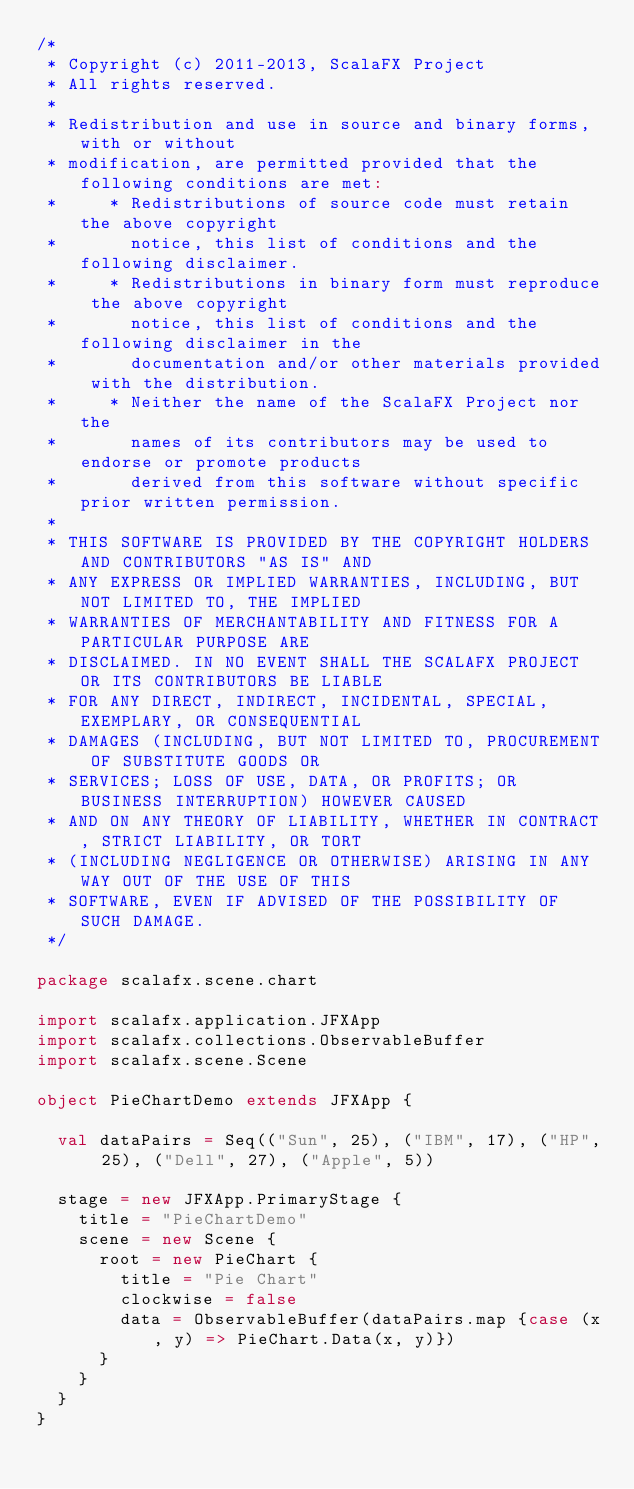<code> <loc_0><loc_0><loc_500><loc_500><_Scala_>/*
 * Copyright (c) 2011-2013, ScalaFX Project
 * All rights reserved.
 *
 * Redistribution and use in source and binary forms, with or without
 * modification, are permitted provided that the following conditions are met:
 *     * Redistributions of source code must retain the above copyright
 *       notice, this list of conditions and the following disclaimer.
 *     * Redistributions in binary form must reproduce the above copyright
 *       notice, this list of conditions and the following disclaimer in the
 *       documentation and/or other materials provided with the distribution.
 *     * Neither the name of the ScalaFX Project nor the
 *       names of its contributors may be used to endorse or promote products
 *       derived from this software without specific prior written permission.
 *
 * THIS SOFTWARE IS PROVIDED BY THE COPYRIGHT HOLDERS AND CONTRIBUTORS "AS IS" AND
 * ANY EXPRESS OR IMPLIED WARRANTIES, INCLUDING, BUT NOT LIMITED TO, THE IMPLIED
 * WARRANTIES OF MERCHANTABILITY AND FITNESS FOR A PARTICULAR PURPOSE ARE
 * DISCLAIMED. IN NO EVENT SHALL THE SCALAFX PROJECT OR ITS CONTRIBUTORS BE LIABLE
 * FOR ANY DIRECT, INDIRECT, INCIDENTAL, SPECIAL, EXEMPLARY, OR CONSEQUENTIAL
 * DAMAGES (INCLUDING, BUT NOT LIMITED TO, PROCUREMENT OF SUBSTITUTE GOODS OR
 * SERVICES; LOSS OF USE, DATA, OR PROFITS; OR BUSINESS INTERRUPTION) HOWEVER CAUSED
 * AND ON ANY THEORY OF LIABILITY, WHETHER IN CONTRACT, STRICT LIABILITY, OR TORT
 * (INCLUDING NEGLIGENCE OR OTHERWISE) ARISING IN ANY WAY OUT OF THE USE OF THIS
 * SOFTWARE, EVEN IF ADVISED OF THE POSSIBILITY OF SUCH DAMAGE.
 */

package scalafx.scene.chart

import scalafx.application.JFXApp
import scalafx.collections.ObservableBuffer
import scalafx.scene.Scene

object PieChartDemo extends JFXApp {

  val dataPairs = Seq(("Sun", 25), ("IBM", 17), ("HP", 25), ("Dell", 27), ("Apple", 5))

  stage = new JFXApp.PrimaryStage {
    title = "PieChartDemo"
    scene = new Scene {
      root = new PieChart {
        title = "Pie Chart"
        clockwise = false
        data = ObservableBuffer(dataPairs.map {case (x, y) => PieChart.Data(x, y)})
      }
    }
  }
}
</code> 